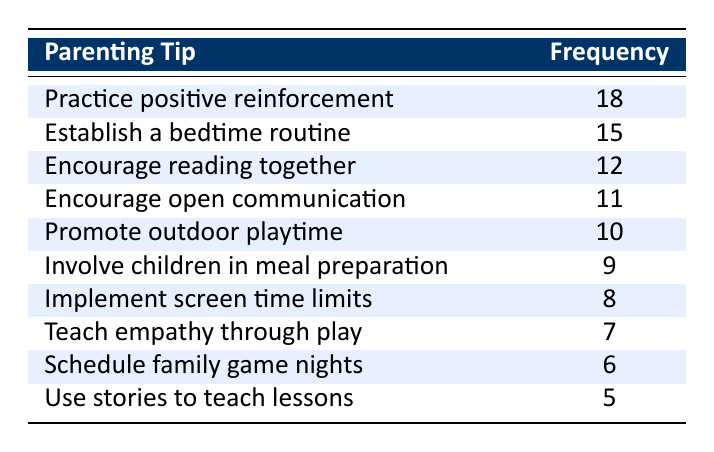What is the most frequently discussed parenting tip? The table shows that "Practice positive reinforcement" has the highest frequency at 18.
Answer: Practice positive reinforcement How many parents discussed "Encourage reading together"? The table indicates that the frequency for "Encourage reading together" is 12, which means 12 parents discussed this tip.
Answer: 12 What is the total frequency of tips related to bedtime routines and open communication? The frequency for "Establish a bedtime routine" is 15 and for "Encourage open communication" is 11. Adding these gives 15 + 11 = 26.
Answer: 26 Is "Teach empathy through play" one of the top three most discussed parenting tips? The frequencies indicate that "Practice positive reinforcement," "Establish a bedtime routine," and "Encourage reading together" are the top three, so "Teach empathy through play" (frequency of 7) is not in the top three.
Answer: No What is the difference in frequency between "Involve children in meal preparation" and "Use stories to teach lessons"? The frequency for "Involve children in meal preparation" is 9 and for "Use stories to teach lessons" is 5. The difference is 9 - 5 = 4.
Answer: 4 